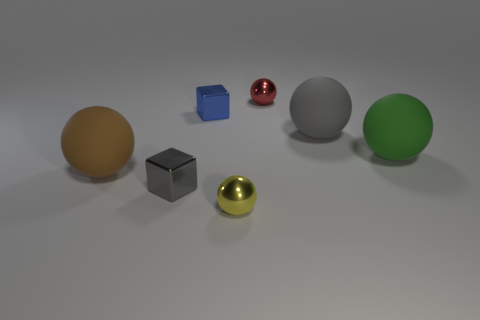Subtract all blue balls. Subtract all yellow cylinders. How many balls are left? 5 Add 2 yellow metallic spheres. How many objects exist? 9 Subtract all balls. How many objects are left? 2 Add 6 small red metallic objects. How many small red metallic objects are left? 7 Add 2 red spheres. How many red spheres exist? 3 Subtract 0 yellow cylinders. How many objects are left? 7 Subtract all tiny gray metal blocks. Subtract all red balls. How many objects are left? 5 